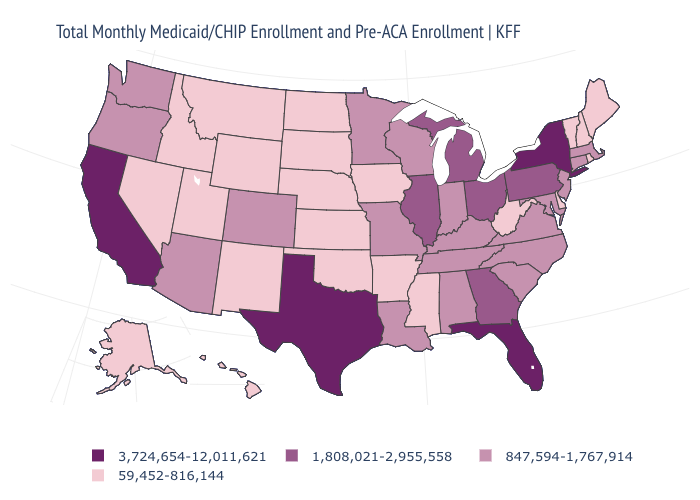Does South Dakota have the lowest value in the MidWest?
Answer briefly. Yes. Among the states that border Illinois , does Missouri have the highest value?
Be succinct. Yes. Does Alaska have a lower value than Idaho?
Write a very short answer. No. Does the map have missing data?
Answer briefly. No. What is the highest value in states that border Nevada?
Answer briefly. 3,724,654-12,011,621. Does the map have missing data?
Give a very brief answer. No. Does the first symbol in the legend represent the smallest category?
Concise answer only. No. Name the states that have a value in the range 3,724,654-12,011,621?
Be succinct. California, Florida, New York, Texas. What is the lowest value in states that border Rhode Island?
Concise answer only. 847,594-1,767,914. Name the states that have a value in the range 1,808,021-2,955,558?
Give a very brief answer. Georgia, Illinois, Michigan, Ohio, Pennsylvania. What is the lowest value in the USA?
Concise answer only. 59,452-816,144. Does Texas have the same value as Florida?
Quick response, please. Yes. What is the highest value in the USA?
Write a very short answer. 3,724,654-12,011,621. Does Texas have the highest value in the USA?
Concise answer only. Yes. Which states have the lowest value in the South?
Quick response, please. Arkansas, Delaware, Mississippi, Oklahoma, West Virginia. 